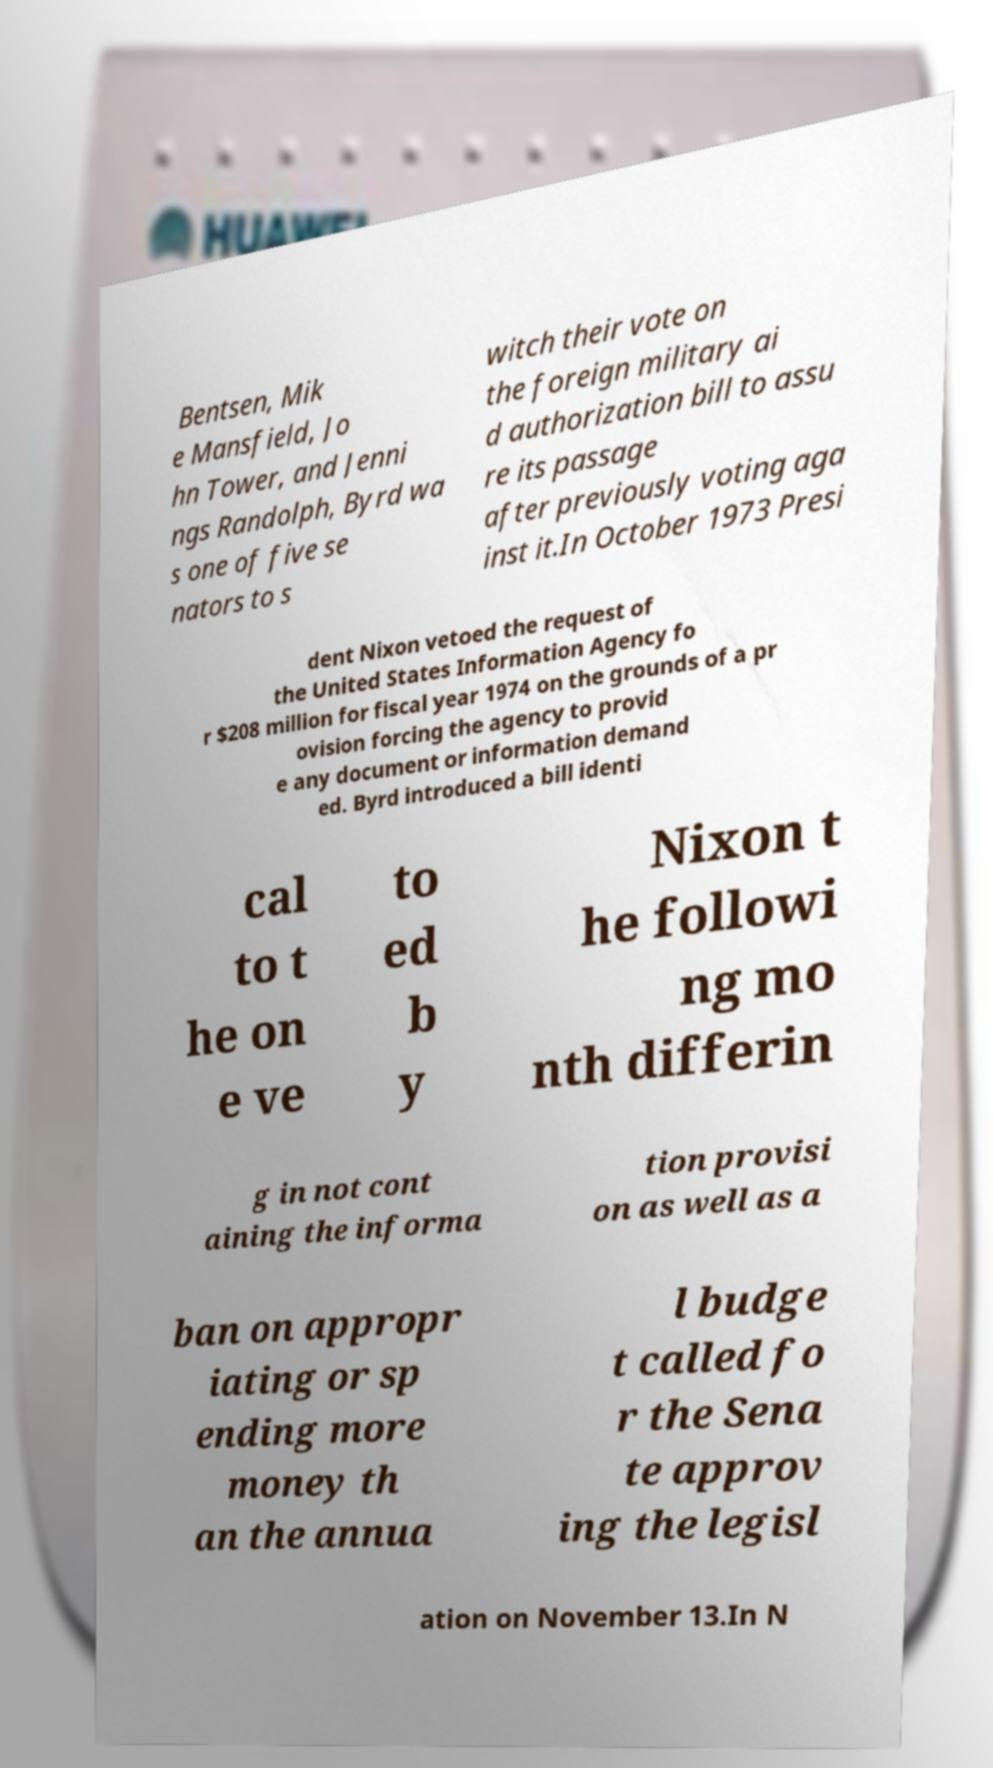There's text embedded in this image that I need extracted. Can you transcribe it verbatim? Bentsen, Mik e Mansfield, Jo hn Tower, and Jenni ngs Randolph, Byrd wa s one of five se nators to s witch their vote on the foreign military ai d authorization bill to assu re its passage after previously voting aga inst it.In October 1973 Presi dent Nixon vetoed the request of the United States Information Agency fo r $208 million for fiscal year 1974 on the grounds of a pr ovision forcing the agency to provid e any document or information demand ed. Byrd introduced a bill identi cal to t he on e ve to ed b y Nixon t he followi ng mo nth differin g in not cont aining the informa tion provisi on as well as a ban on appropr iating or sp ending more money th an the annua l budge t called fo r the Sena te approv ing the legisl ation on November 13.In N 